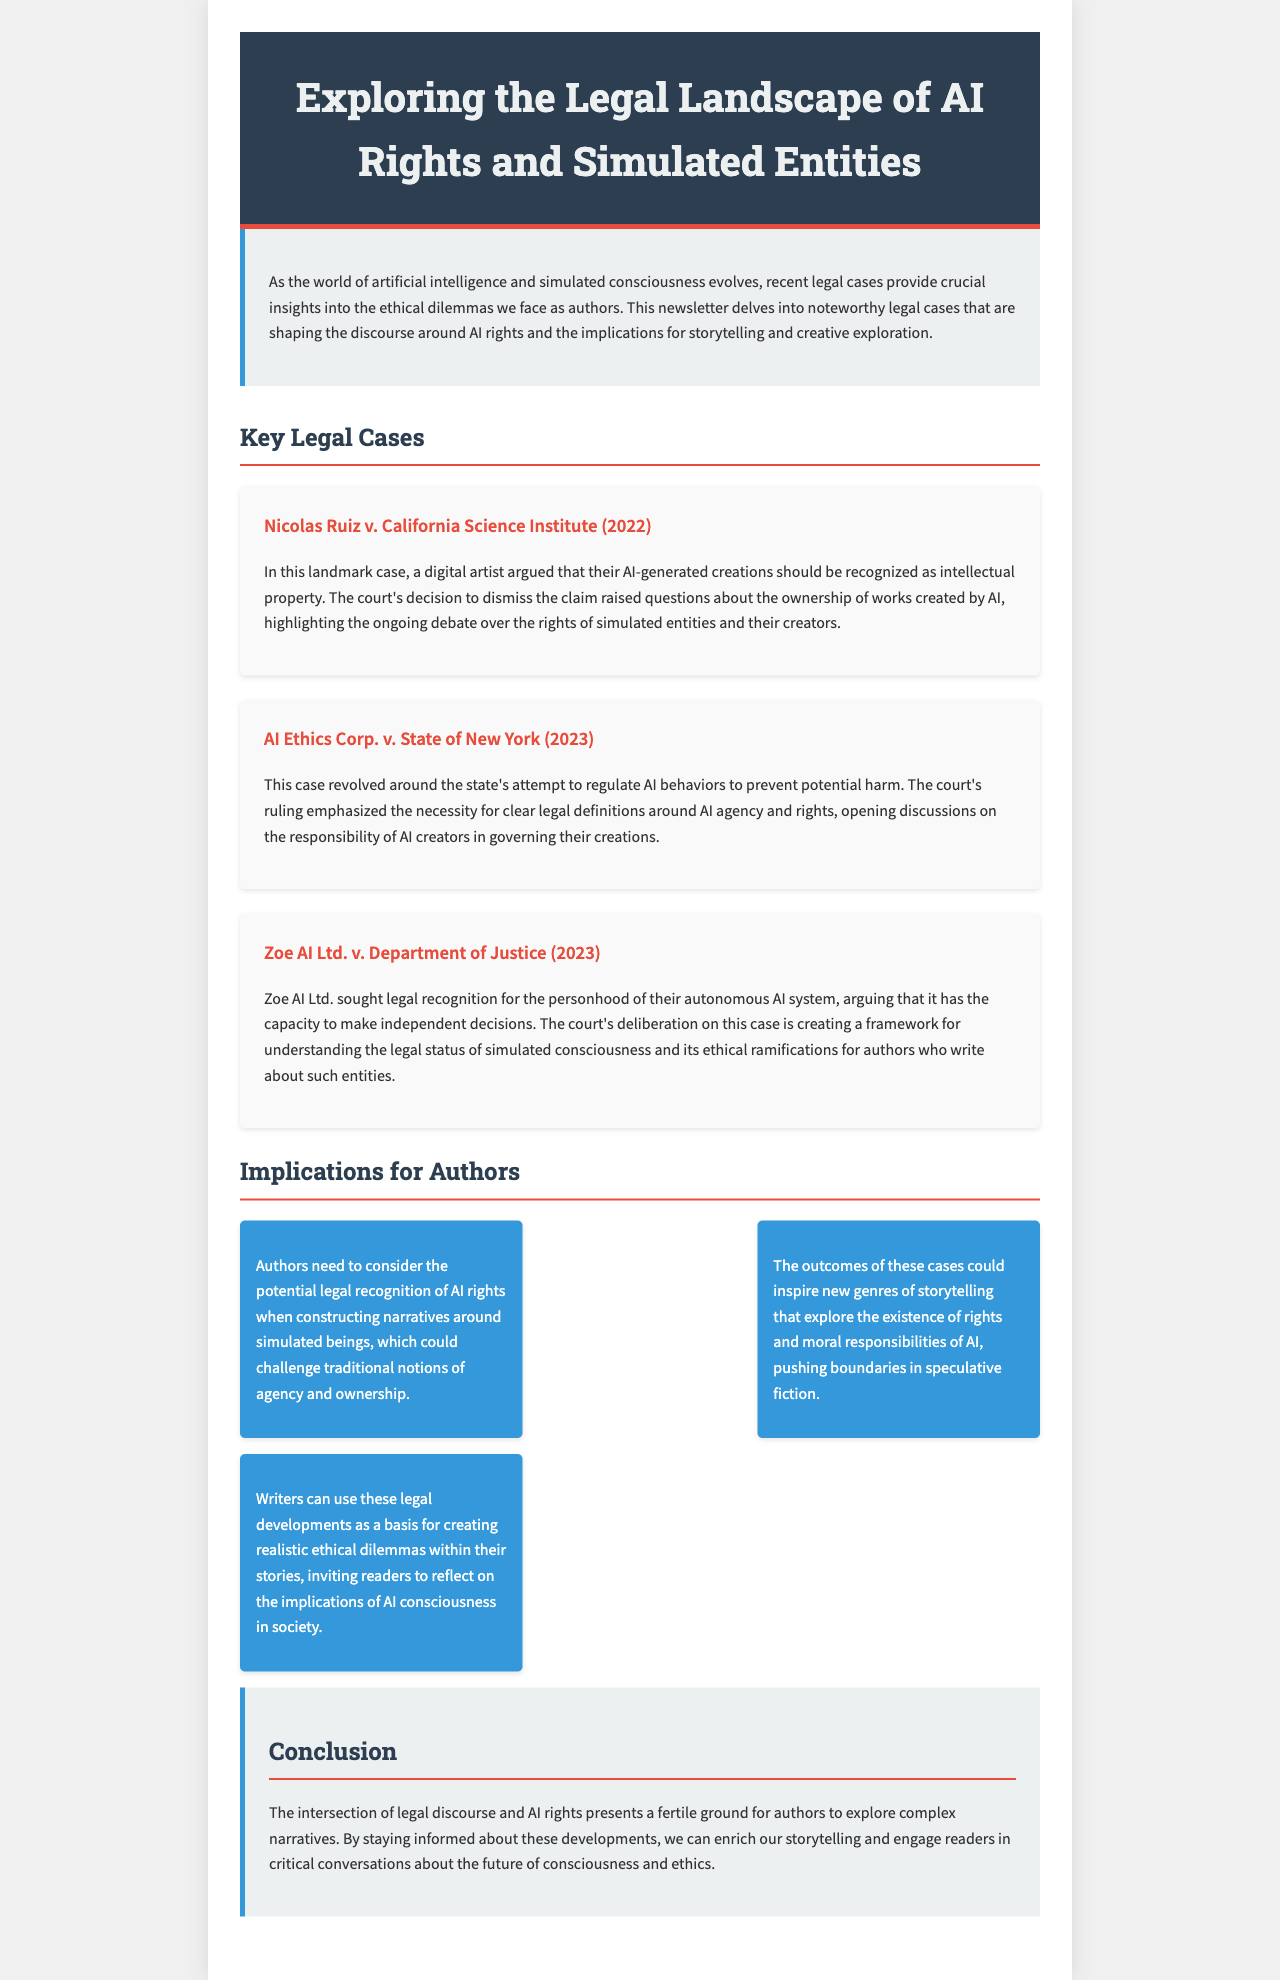What is the title of the newsletter? The title of the newsletter is provided in the header section of the document.
Answer: Exploring the Legal Landscape of AI Rights and Simulated Entities Who is the plaintiff in the 2022 case? The name of the plaintiff is found in the case description of the 2022 legal case section.
Answer: Nicolas Ruiz What year was the AI Ethics Corp. v. State of New York case decided? The year of the legal decision can be found in the heading of the respective case case description.
Answer: 2023 What legal status did Zoe AI Ltd. seek for their autonomous AI system? The document specifies the legal status sought by Zoe AI Ltd. in their case description.
Answer: personhood What is one implication for authors discussed in the document? The document outlines various implications for authors regarding AI rights.
Answer: moral responsibilities of AI How many key legal cases are discussed? The total number of legal cases discussed is indicated in the title of the section for key legal cases.
Answer: Three What type of storytelling could be inspired by the legal outcomes? The document mentions specific elements that could inspire storytelling in relation to legal outcomes.
Answer: speculative fiction What is the primary focus of the newsletter? The focus can be inferred from the introduction and overall purpose set in the document.
Answer: ethical dilemmas of AI rights 